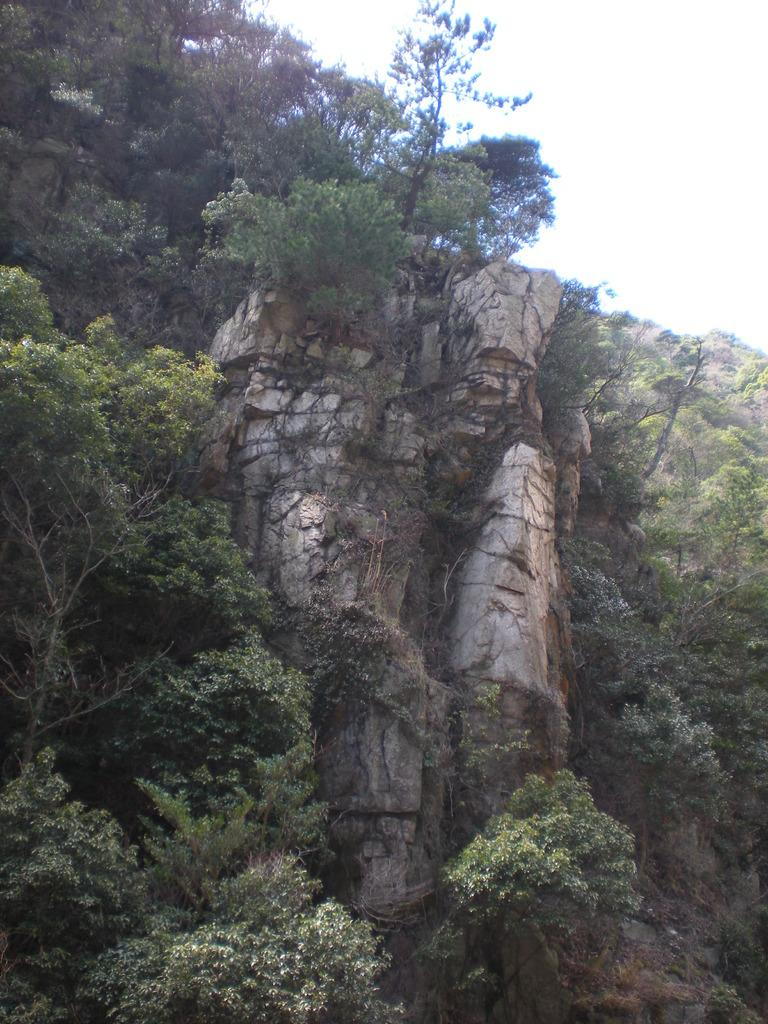What type of landscape feature is present in the image? There is a hill in the image. What other natural elements can be seen in the image? There are trees in the image. Are there any other objects or features present in the image? Yes, there is a rock in the image. How would you describe the weather in the image? The sky is cloudy in the image. What type of spark can be seen coming from the structure in the image? There is no structure or spark present in the image; it features a hill, trees, a rock, and a cloudy sky. 